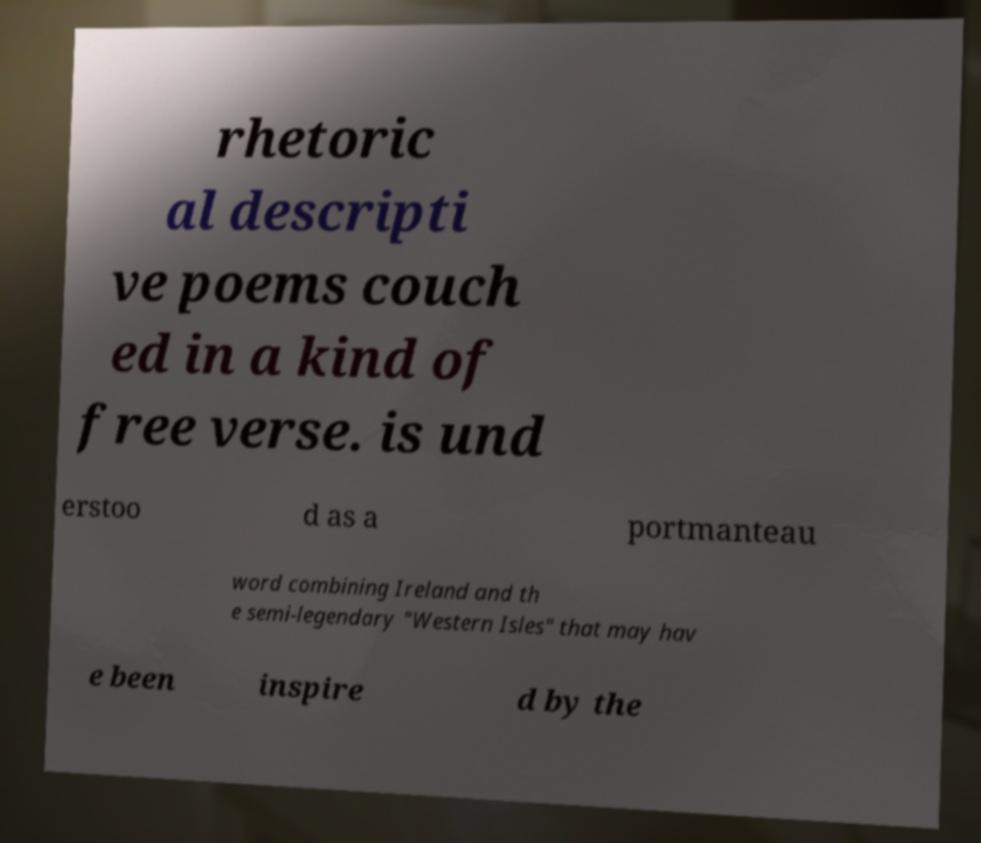I need the written content from this picture converted into text. Can you do that? rhetoric al descripti ve poems couch ed in a kind of free verse. is und erstoo d as a portmanteau word combining Ireland and th e semi-legendary "Western Isles" that may hav e been inspire d by the 